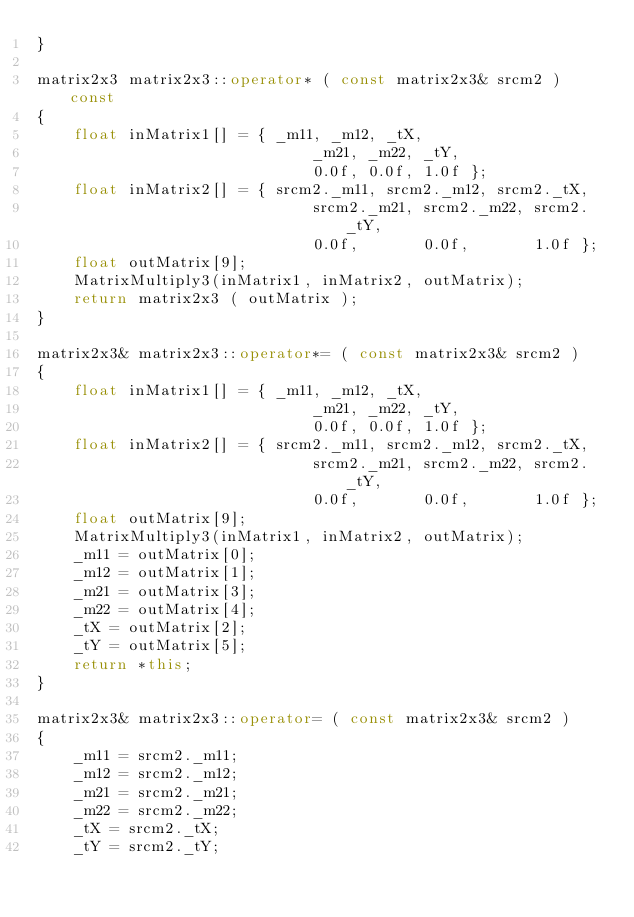<code> <loc_0><loc_0><loc_500><loc_500><_C++_>}

matrix2x3 matrix2x3::operator* ( const matrix2x3& srcm2 ) const
{
	float inMatrix1[] = { _m11, _m12, _tX,
                              _m21, _m22, _tY,
                              0.0f, 0.0f, 1.0f };
	float inMatrix2[] = { srcm2._m11, srcm2._m12, srcm2._tX,
                              srcm2._m21, srcm2._m22, srcm2._tY,
                              0.0f,       0.0f,       1.0f };
	float outMatrix[9];
	MatrixMultiply3(inMatrix1, inMatrix2, outMatrix);
	return matrix2x3 ( outMatrix );
}

matrix2x3& matrix2x3::operator*= ( const matrix2x3& srcm2 )
{
	float inMatrix1[] = { _m11, _m12, _tX,
                              _m21, _m22, _tY,
                              0.0f, 0.0f, 1.0f };
	float inMatrix2[] = { srcm2._m11, srcm2._m12, srcm2._tX,
                              srcm2._m21, srcm2._m22, srcm2._tY,
                              0.0f,       0.0f,       1.0f };
	float outMatrix[9];
	MatrixMultiply3(inMatrix1, inMatrix2, outMatrix);
	_m11 = outMatrix[0];
	_m12 = outMatrix[1];
	_m21 = outMatrix[3];
	_m22 = outMatrix[4];
	_tX = outMatrix[2];
	_tY = outMatrix[5];
	return *this;
}

matrix2x3& matrix2x3::operator= ( const matrix2x3& srcm2 )
{
	_m11 = srcm2._m11;
	_m12 = srcm2._m12;
	_m21 = srcm2._m21;
	_m22 = srcm2._m22;
	_tX = srcm2._tX;
	_tY = srcm2._tY;</code> 